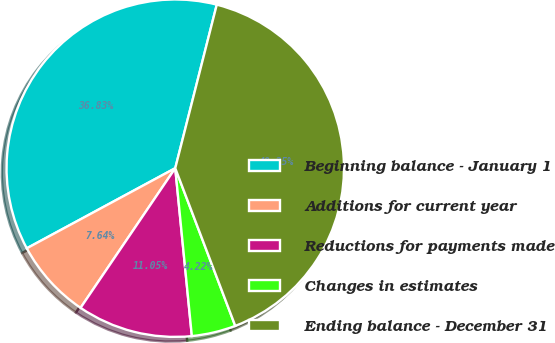Convert chart to OTSL. <chart><loc_0><loc_0><loc_500><loc_500><pie_chart><fcel>Beginning balance - January 1<fcel>Additions for current year<fcel>Reductions for payments made<fcel>Changes in estimates<fcel>Ending balance - December 31<nl><fcel>36.83%<fcel>7.64%<fcel>11.05%<fcel>4.22%<fcel>40.25%<nl></chart> 